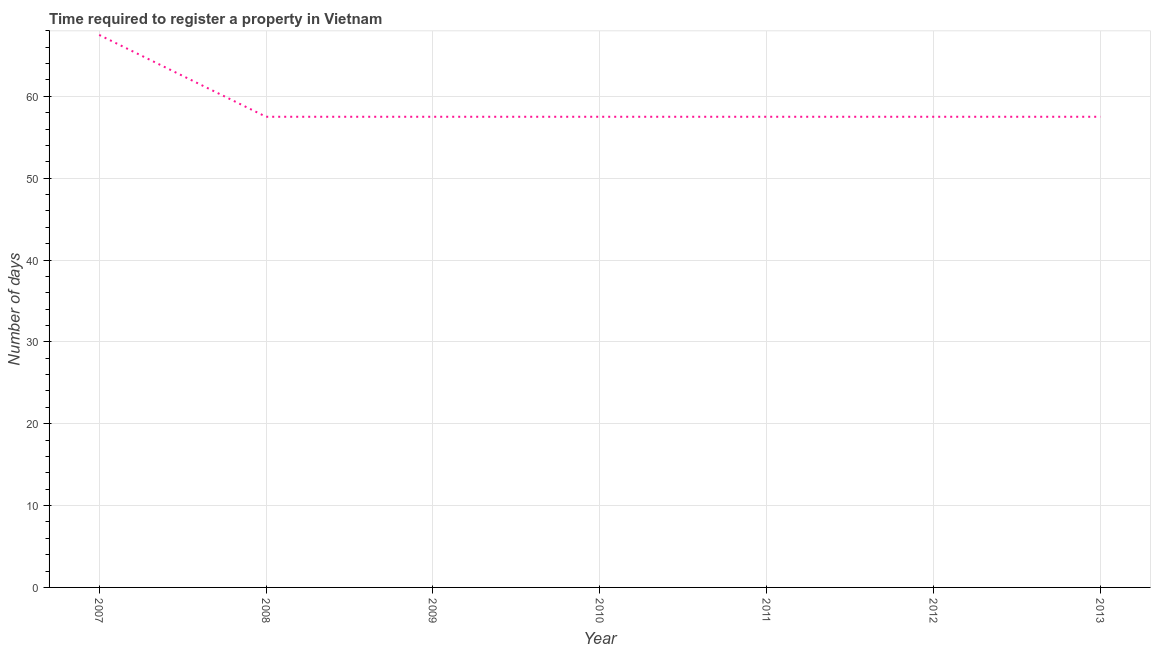What is the number of days required to register property in 2008?
Provide a short and direct response. 57.5. Across all years, what is the maximum number of days required to register property?
Your answer should be compact. 67.5. Across all years, what is the minimum number of days required to register property?
Your answer should be compact. 57.5. In which year was the number of days required to register property minimum?
Offer a terse response. 2008. What is the sum of the number of days required to register property?
Provide a short and direct response. 412.5. What is the average number of days required to register property per year?
Your response must be concise. 58.93. What is the median number of days required to register property?
Provide a succinct answer. 57.5. In how many years, is the number of days required to register property greater than 2 days?
Keep it short and to the point. 7. What is the ratio of the number of days required to register property in 2007 to that in 2009?
Keep it short and to the point. 1.17. Is the number of days required to register property in 2007 less than that in 2012?
Your answer should be compact. No. Is the difference between the number of days required to register property in 2007 and 2008 greater than the difference between any two years?
Your answer should be very brief. Yes. Is the sum of the number of days required to register property in 2007 and 2008 greater than the maximum number of days required to register property across all years?
Provide a succinct answer. Yes. How many lines are there?
Ensure brevity in your answer.  1. What is the title of the graph?
Your answer should be very brief. Time required to register a property in Vietnam. What is the label or title of the X-axis?
Ensure brevity in your answer.  Year. What is the label or title of the Y-axis?
Offer a terse response. Number of days. What is the Number of days of 2007?
Your answer should be very brief. 67.5. What is the Number of days of 2008?
Provide a succinct answer. 57.5. What is the Number of days of 2009?
Make the answer very short. 57.5. What is the Number of days of 2010?
Offer a very short reply. 57.5. What is the Number of days in 2011?
Your response must be concise. 57.5. What is the Number of days in 2012?
Provide a succinct answer. 57.5. What is the Number of days of 2013?
Your answer should be very brief. 57.5. What is the difference between the Number of days in 2007 and 2009?
Offer a terse response. 10. What is the difference between the Number of days in 2007 and 2013?
Make the answer very short. 10. What is the difference between the Number of days in 2008 and 2011?
Keep it short and to the point. 0. What is the difference between the Number of days in 2008 and 2012?
Provide a succinct answer. 0. What is the difference between the Number of days in 2008 and 2013?
Your answer should be compact. 0. What is the difference between the Number of days in 2009 and 2010?
Give a very brief answer. 0. What is the difference between the Number of days in 2009 and 2011?
Your answer should be very brief. 0. What is the difference between the Number of days in 2009 and 2012?
Your answer should be very brief. 0. What is the difference between the Number of days in 2009 and 2013?
Offer a very short reply. 0. What is the difference between the Number of days in 2010 and 2011?
Ensure brevity in your answer.  0. What is the difference between the Number of days in 2010 and 2013?
Offer a terse response. 0. What is the difference between the Number of days in 2011 and 2012?
Provide a succinct answer. 0. What is the difference between the Number of days in 2011 and 2013?
Provide a succinct answer. 0. What is the difference between the Number of days in 2012 and 2013?
Make the answer very short. 0. What is the ratio of the Number of days in 2007 to that in 2008?
Ensure brevity in your answer.  1.17. What is the ratio of the Number of days in 2007 to that in 2009?
Your answer should be compact. 1.17. What is the ratio of the Number of days in 2007 to that in 2010?
Your answer should be very brief. 1.17. What is the ratio of the Number of days in 2007 to that in 2011?
Provide a short and direct response. 1.17. What is the ratio of the Number of days in 2007 to that in 2012?
Keep it short and to the point. 1.17. What is the ratio of the Number of days in 2007 to that in 2013?
Offer a terse response. 1.17. What is the ratio of the Number of days in 2008 to that in 2011?
Make the answer very short. 1. What is the ratio of the Number of days in 2008 to that in 2012?
Offer a terse response. 1. What is the ratio of the Number of days in 2009 to that in 2012?
Provide a short and direct response. 1. What is the ratio of the Number of days in 2009 to that in 2013?
Your response must be concise. 1. What is the ratio of the Number of days in 2010 to that in 2012?
Keep it short and to the point. 1. What is the ratio of the Number of days in 2011 to that in 2012?
Keep it short and to the point. 1. What is the ratio of the Number of days in 2011 to that in 2013?
Make the answer very short. 1. 